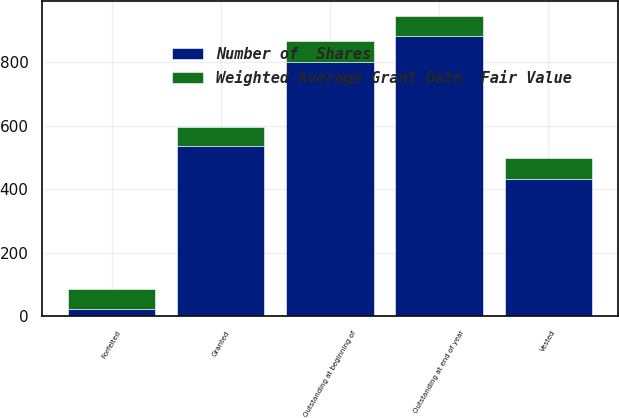Convert chart to OTSL. <chart><loc_0><loc_0><loc_500><loc_500><stacked_bar_chart><ecel><fcel>Outstanding at beginning of<fcel>Granted<fcel>Vested<fcel>Forfeited<fcel>Outstanding at end of year<nl><fcel>Number of  Shares<fcel>799<fcel>537<fcel>432<fcel>22<fcel>882<nl><fcel>Weighted Average Grant Date  Fair Value<fcel>66.76<fcel>59.34<fcel>65.77<fcel>62.94<fcel>62.82<nl></chart> 